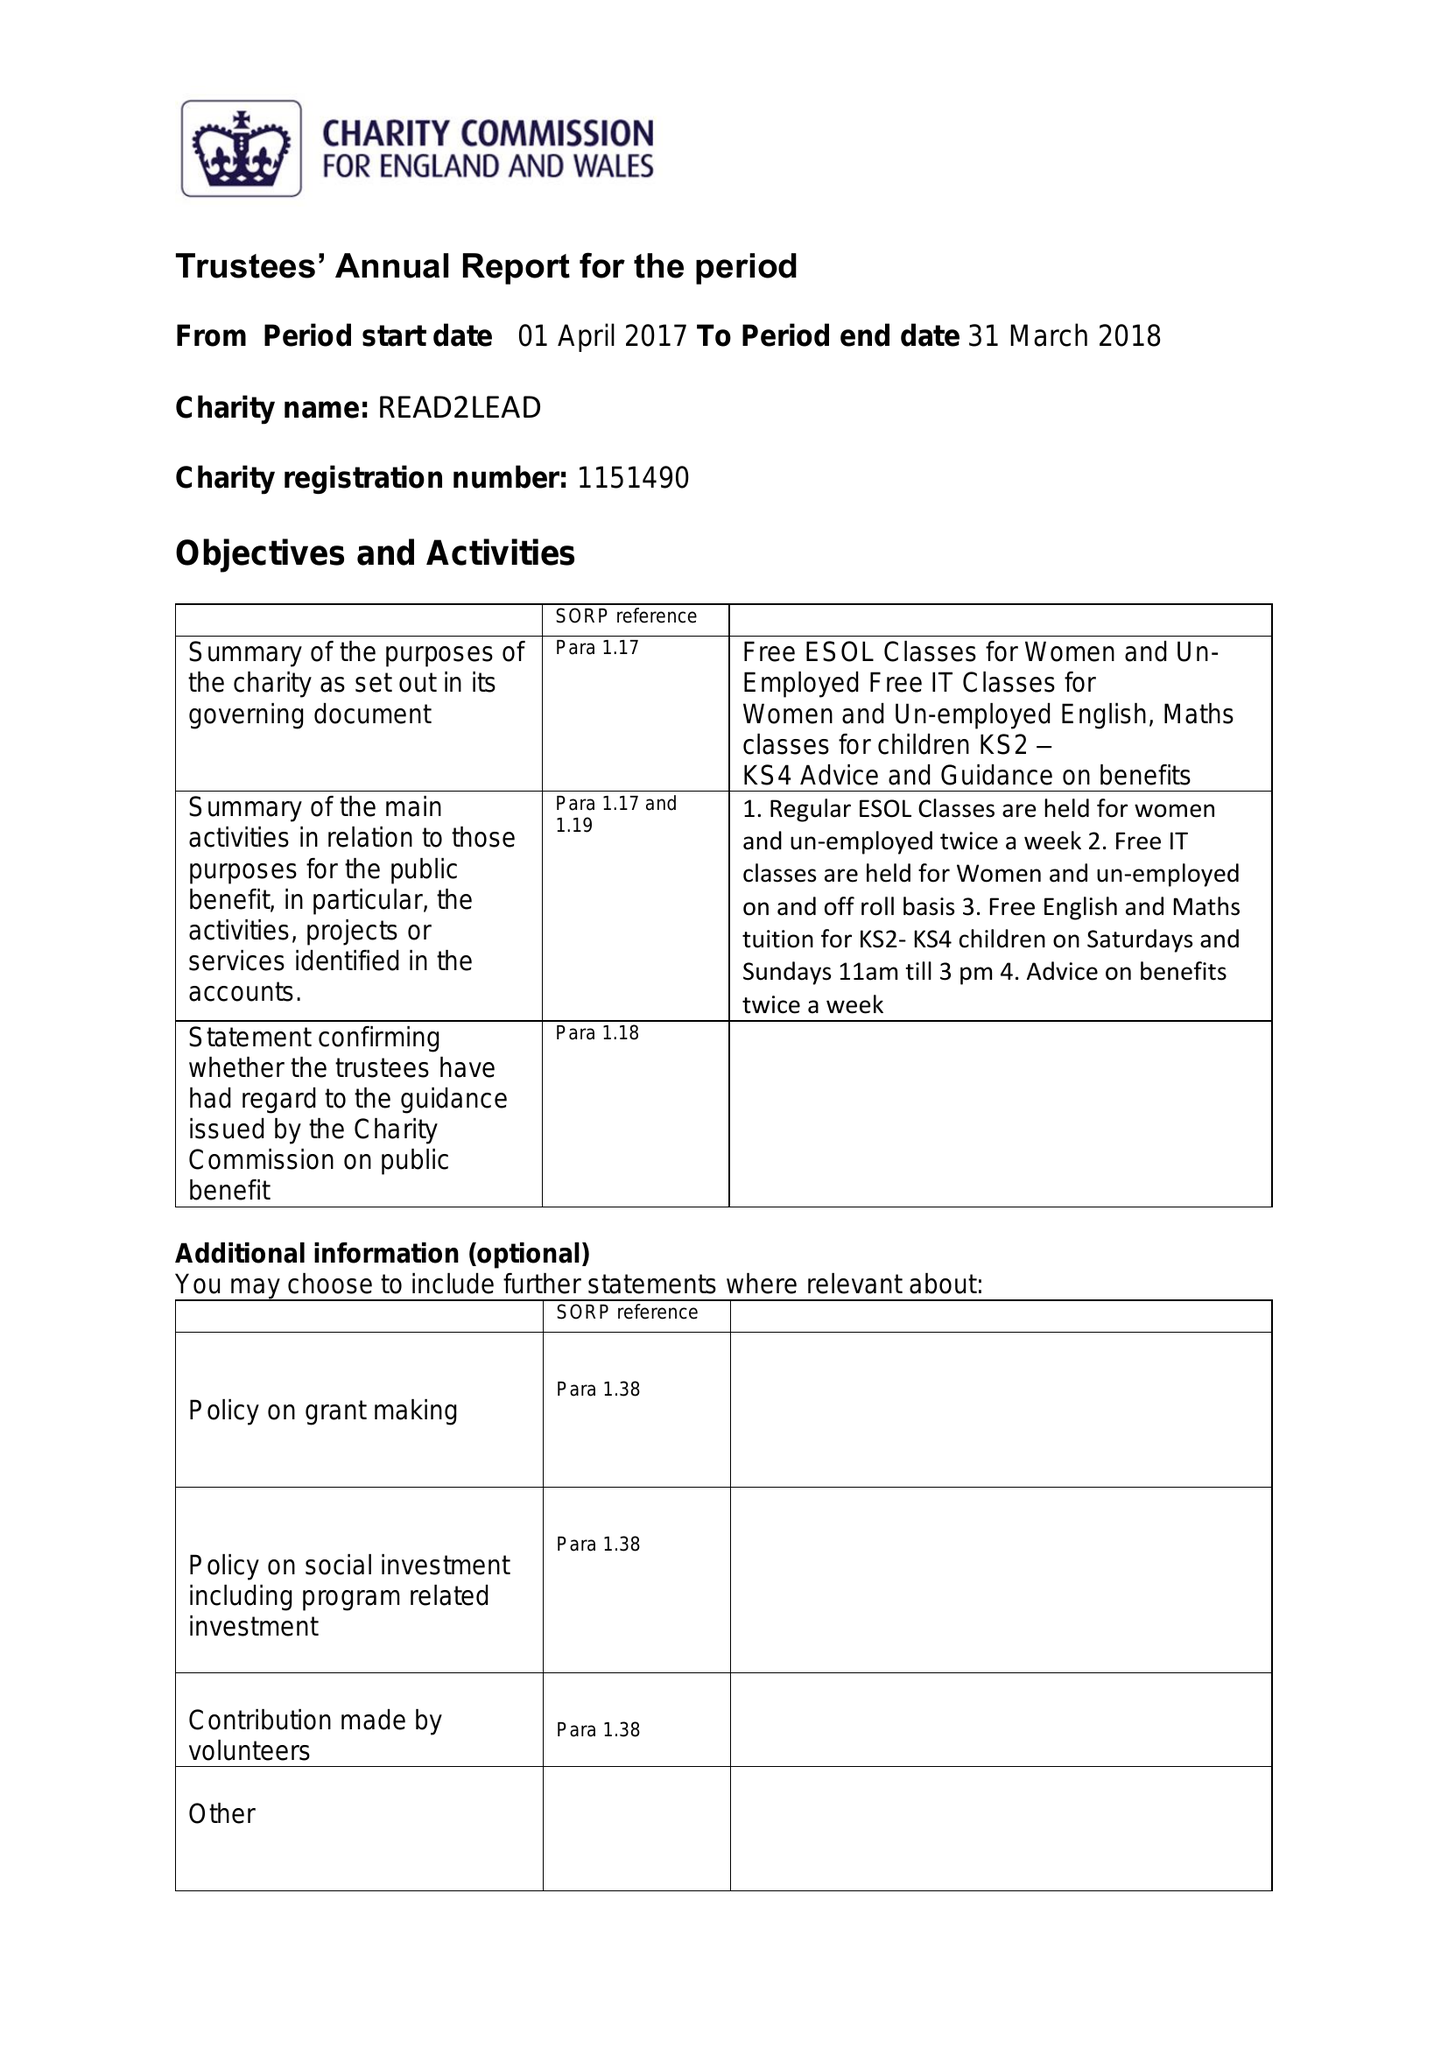What is the value for the address__post_town?
Answer the question using a single word or phrase. BIRMINGHAM 